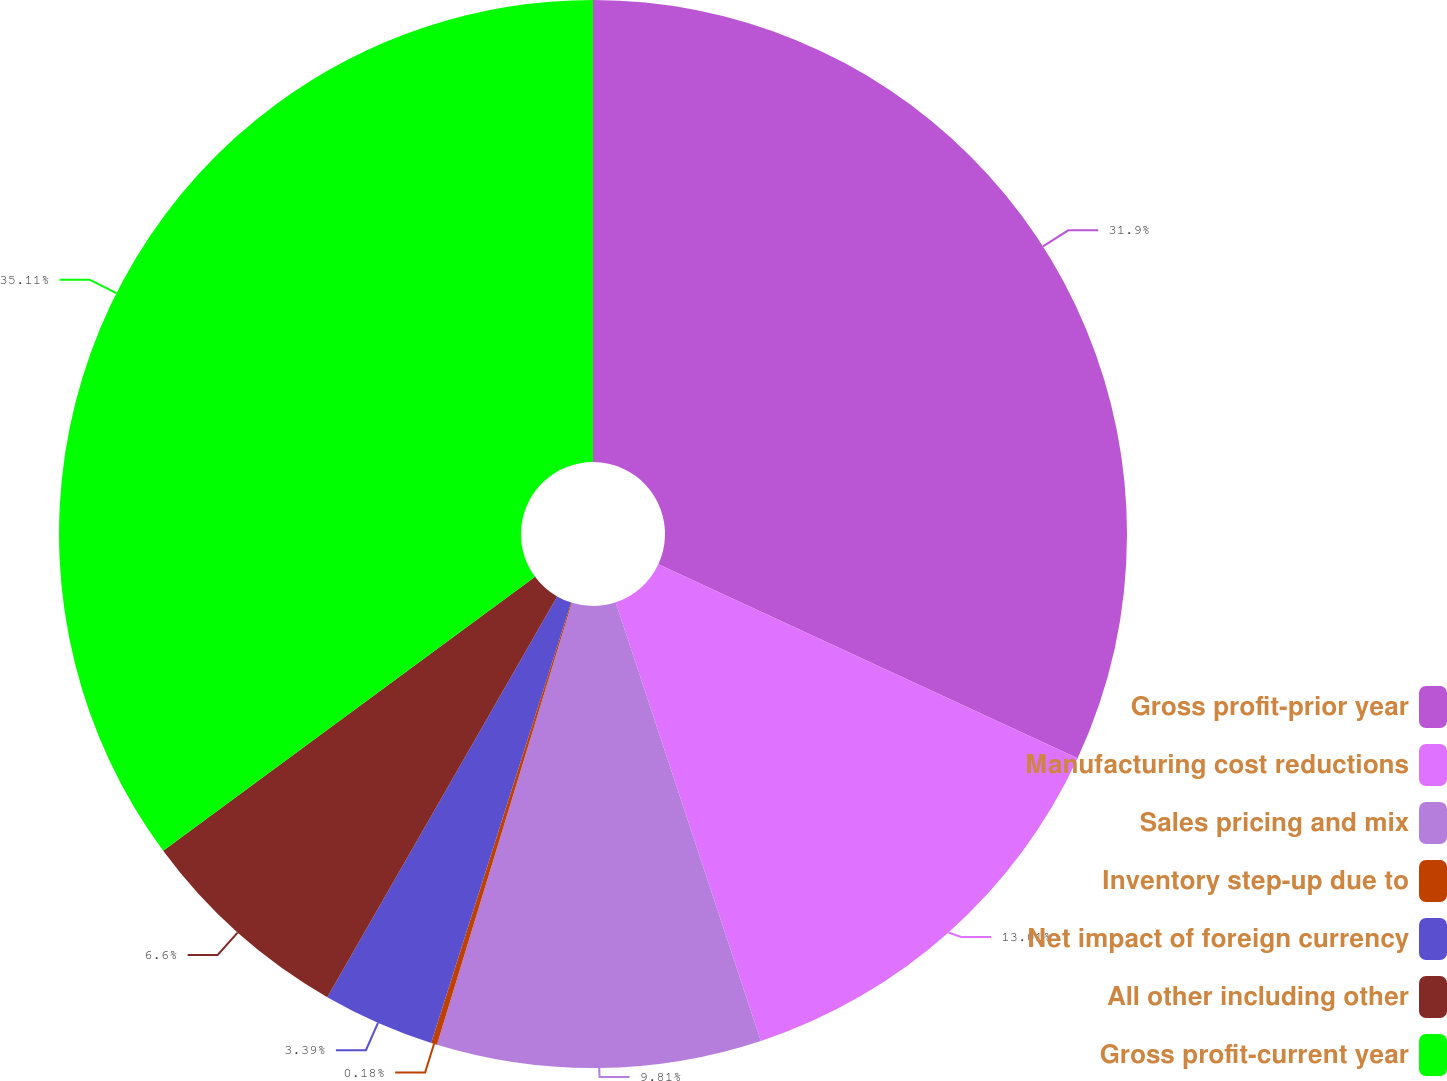Convert chart. <chart><loc_0><loc_0><loc_500><loc_500><pie_chart><fcel>Gross profit-prior year<fcel>Manufacturing cost reductions<fcel>Sales pricing and mix<fcel>Inventory step-up due to<fcel>Net impact of foreign currency<fcel>All other including other<fcel>Gross profit-current year<nl><fcel>31.9%<fcel>13.01%<fcel>9.81%<fcel>0.18%<fcel>3.39%<fcel>6.6%<fcel>35.11%<nl></chart> 